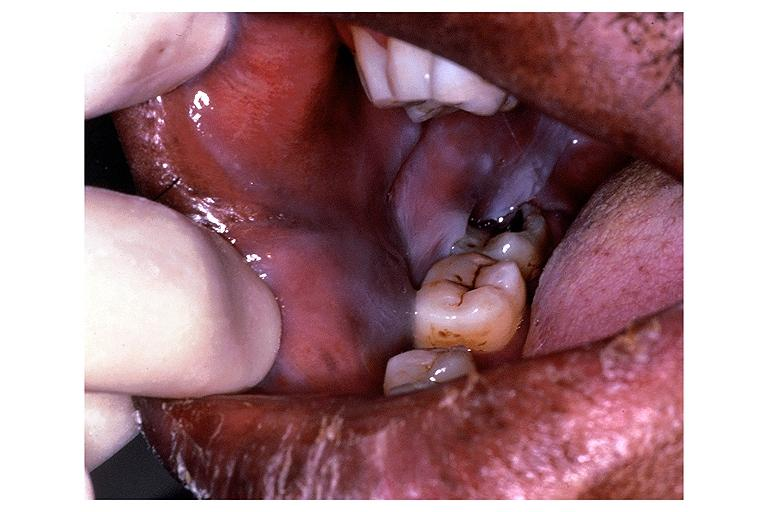does this image show leukoedema?
Answer the question using a single word or phrase. Yes 